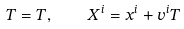Convert formula to latex. <formula><loc_0><loc_0><loc_500><loc_500>T = T , \quad X ^ { i } = x ^ { i } + v ^ { i } T</formula> 